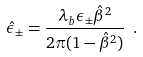<formula> <loc_0><loc_0><loc_500><loc_500>\hat { \epsilon } _ { \pm } = \frac { \lambda _ { b } \epsilon _ { \pm } \hat { \beta } ^ { 2 } } { 2 \pi ( 1 - \hat { \beta } ^ { 2 } ) } \ .</formula> 